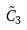<formula> <loc_0><loc_0><loc_500><loc_500>\tilde { C } _ { 3 }</formula> 